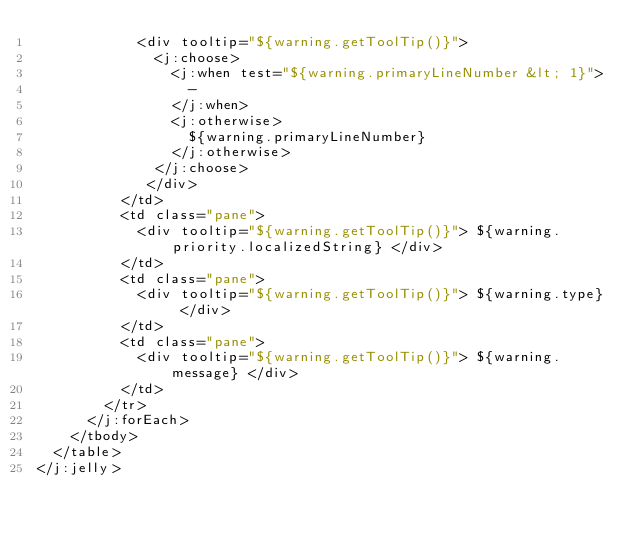<code> <loc_0><loc_0><loc_500><loc_500><_XML_>            <div tooltip="${warning.getToolTip()}">
              <j:choose>
                <j:when test="${warning.primaryLineNumber &lt; 1}">
                  -
                </j:when>
                <j:otherwise>
                  ${warning.primaryLineNumber}
                </j:otherwise>
              </j:choose>
             </div>
          </td>
          <td class="pane">
            <div tooltip="${warning.getToolTip()}"> ${warning.priority.localizedString} </div>
          </td>
          <td class="pane">
            <div tooltip="${warning.getToolTip()}"> ${warning.type} </div>
          </td>
          <td class="pane">
            <div tooltip="${warning.getToolTip()}"> ${warning.message} </div>
          </td>
        </tr>
      </j:forEach>
    </tbody>
  </table>
</j:jelly>
</code> 